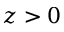Convert formula to latex. <formula><loc_0><loc_0><loc_500><loc_500>z > 0</formula> 